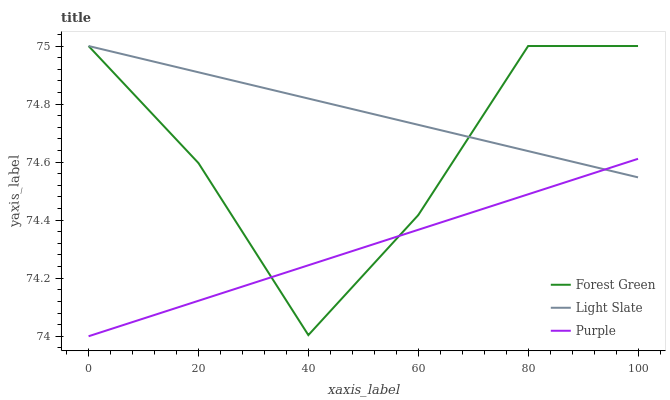Does Forest Green have the minimum area under the curve?
Answer yes or no. No. Does Forest Green have the maximum area under the curve?
Answer yes or no. No. Is Purple the smoothest?
Answer yes or no. No. Is Purple the roughest?
Answer yes or no. No. Does Forest Green have the lowest value?
Answer yes or no. No. Does Purple have the highest value?
Answer yes or no. No. 